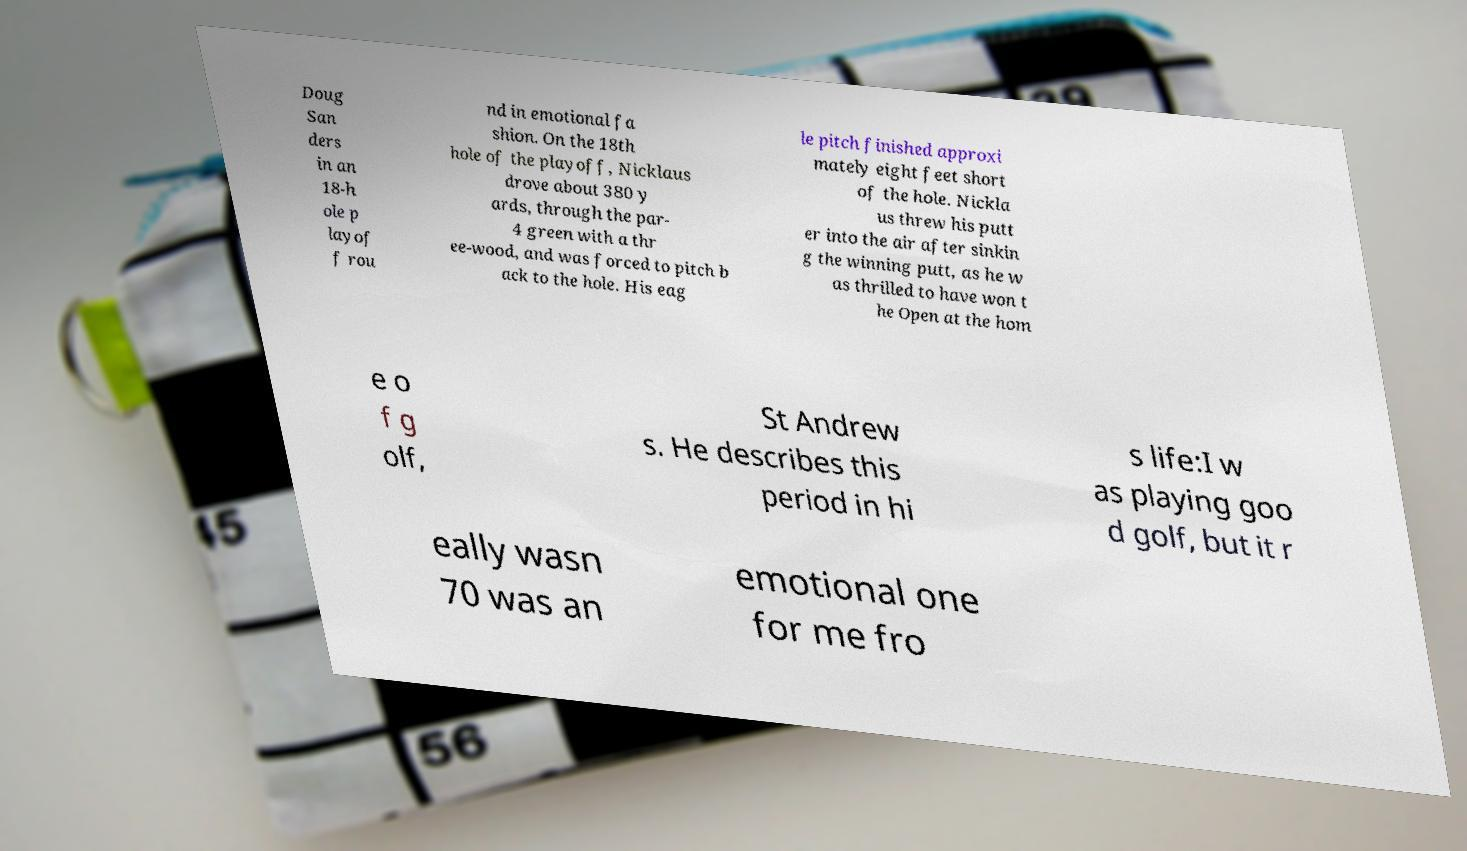Could you assist in decoding the text presented in this image and type it out clearly? Doug San ders in an 18-h ole p layof f rou nd in emotional fa shion. On the 18th hole of the playoff, Nicklaus drove about 380 y ards, through the par- 4 green with a thr ee-wood, and was forced to pitch b ack to the hole. His eag le pitch finished approxi mately eight feet short of the hole. Nickla us threw his putt er into the air after sinkin g the winning putt, as he w as thrilled to have won t he Open at the hom e o f g olf, St Andrew s. He describes this period in hi s life:I w as playing goo d golf, but it r eally wasn 70 was an emotional one for me fro 